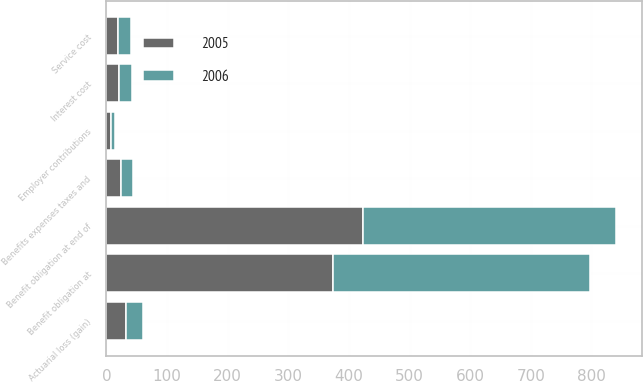Convert chart. <chart><loc_0><loc_0><loc_500><loc_500><stacked_bar_chart><ecel><fcel>Benefit obligation at<fcel>Service cost<fcel>Interest cost<fcel>Actuarial loss (gain)<fcel>Benefits expenses taxes and<fcel>Benefit obligation at end of<fcel>Employer contributions<nl><fcel>2006<fcel>423.2<fcel>21.5<fcel>21.2<fcel>28.2<fcel>20.2<fcel>417.5<fcel>7.4<nl><fcel>2005<fcel>374.4<fcel>19.3<fcel>21.2<fcel>32<fcel>23.7<fcel>423.2<fcel>7<nl></chart> 